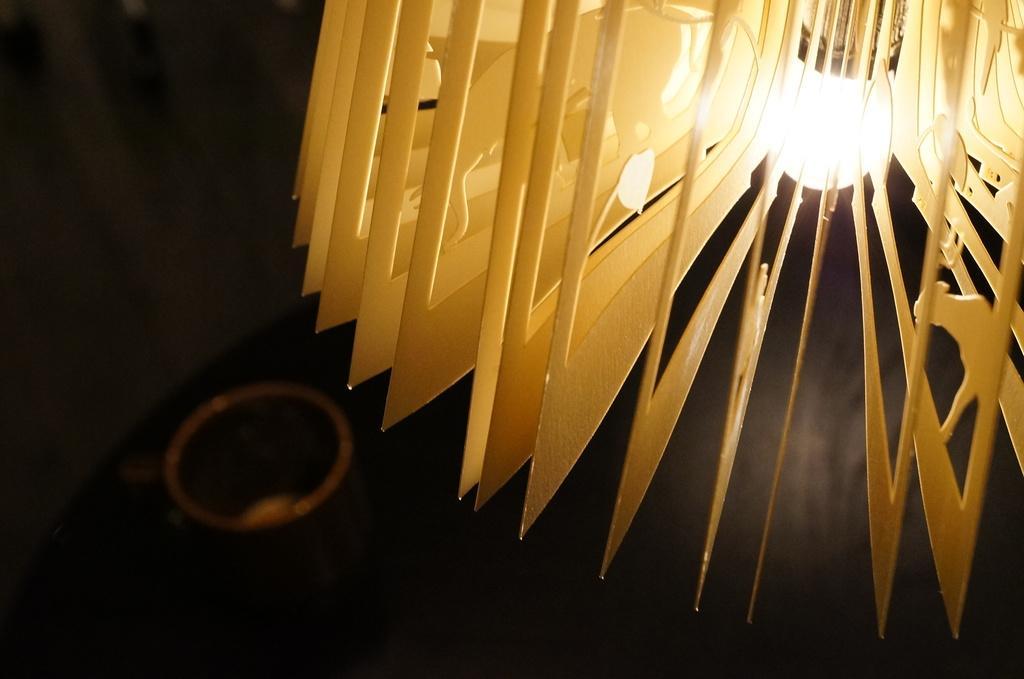Describe this image in one or two sentences. In this image we can see a light with frames. Background there is a blur view. Here we can see some object and black color. 